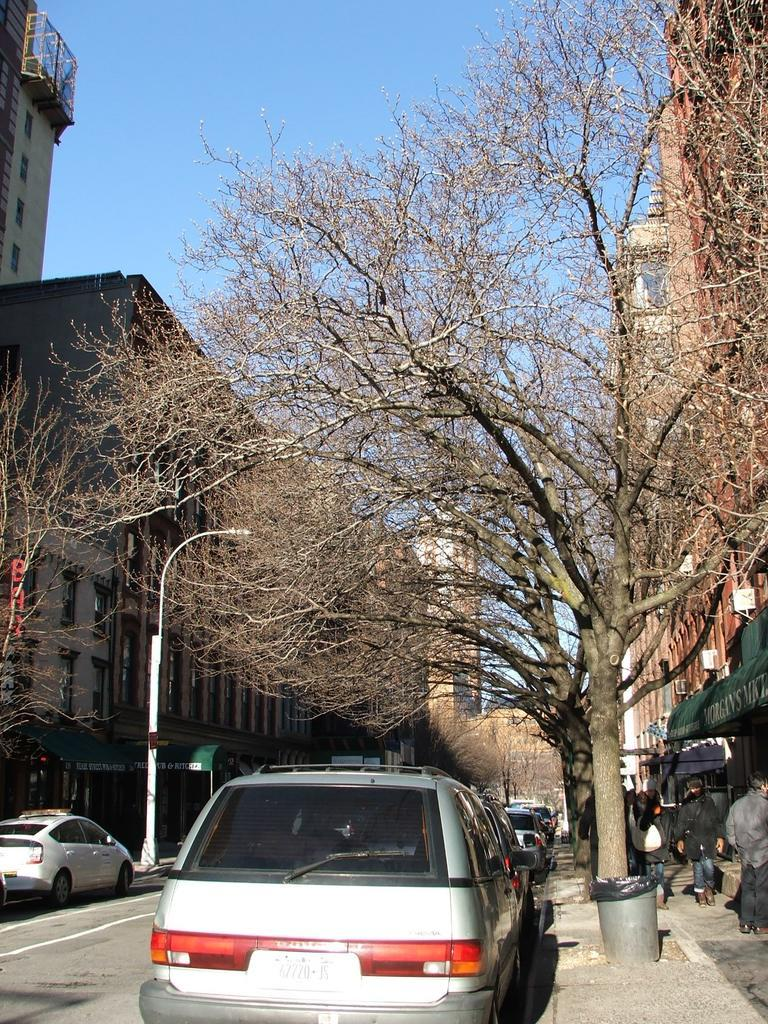What can be seen on the road in the image? There are vehicles on the road in the image. What type of natural elements are visible in the image? Trees are visible in the image. What type of man-made structures are present in the image? Buildings are present in the image. Where are people located in the image? People are visible on the right side of the image. What is the color of the sky in the image? The sky is blue in the image. What type of scientific experiment is being conducted with the sheep in the image? There are no sheep present in the image. 